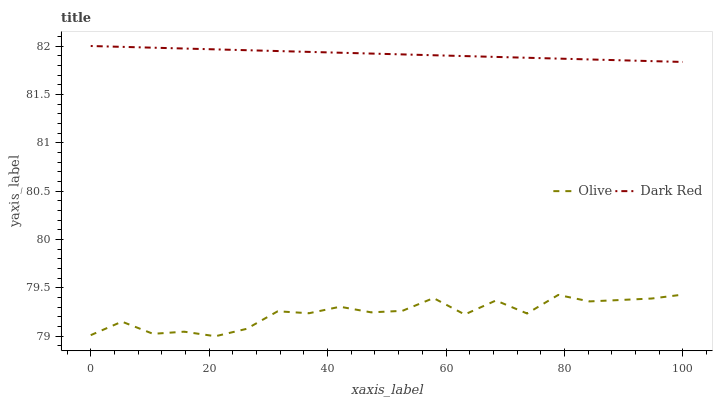Does Olive have the minimum area under the curve?
Answer yes or no. Yes. Does Dark Red have the maximum area under the curve?
Answer yes or no. Yes. Does Dark Red have the minimum area under the curve?
Answer yes or no. No. Is Dark Red the smoothest?
Answer yes or no. Yes. Is Olive the roughest?
Answer yes or no. Yes. Is Dark Red the roughest?
Answer yes or no. No. Does Dark Red have the lowest value?
Answer yes or no. No. Does Dark Red have the highest value?
Answer yes or no. Yes. Is Olive less than Dark Red?
Answer yes or no. Yes. Is Dark Red greater than Olive?
Answer yes or no. Yes. Does Olive intersect Dark Red?
Answer yes or no. No. 